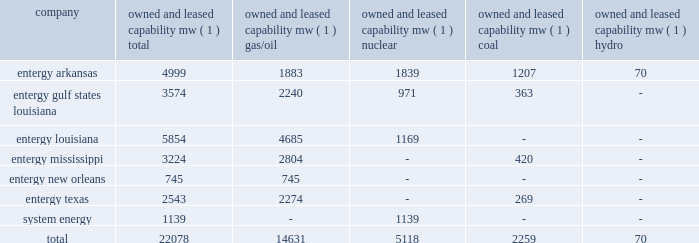Part i item 1 entergy corporation , utility operating companies , and system energy louisiana parishes in which it holds non-exclusive franchises .
Entergy louisiana's electric franchises expire during 2009-2036 .
Entergy mississippi has received from the mpsc certificates of public convenience and necessity to provide electric service to areas within 45 counties , including a number of municipalities , in western mississippi .
Under mississippi statutory law , such certificates are exclusive .
Entergy mississippi may continue to serve in such municipalities upon payment of a statutory franchise fee , regardless of whether an original municipal franchise is still in existence .
Entergy new orleans provides electric and gas service in the city of new orleans pursuant to city ordinances ( except electric service in algiers , which is provided by entergy louisiana ) .
These ordinances contain a continuing option for the city of new orleans to purchase entergy new orleans' electric and gas utility properties .
Entergy texas holds a certificate of convenience and necessity from the puct to provide electric service to areas within approximately 24 counties in eastern texas , and holds non-exclusive franchises to provide electric service in approximately 65 incorporated municipalities .
Entergy texas typically is granted 50-year franchises .
Entergy texas' electric franchises expire during 2009-2045 .
The business of system energy is limited to wholesale power sales .
It has no distribution franchises .
Property and other generation resources generating stations the total capability of the generating stations owned and leased by the utility operating companies and system energy as of december 31 , 2008 , is indicated below: .
( 1 ) "owned and leased capability" is the dependable load carrying capability as demonstrated under actual operating conditions based on the primary fuel ( assuming no curtailments ) that each station was designed to utilize .
The entergy system's load and capacity projections are reviewed periodically to assess the need and timing for additional generating capacity and interconnections .
These reviews consider existing and projected demand , the availability and price of power , the location of new load , and the economy .
Summer peak load in the entergy system service territory has averaged 21039 mw from 2002-2008 .
Due to changing use patterns , peak load growth has nearly flattened while annual energy use continues to grow .
In the 2002 time period , the entergy system's long-term capacity resources , allowing for an adequate reserve margin , were approximately 3000 mw less than the total capacity required for peak period demands .
In this time period entergy met its capacity shortages almost entirely through short-term power purchases in the wholesale spot market .
In the fall of 2002 , the entergy system began a program to add new resources to its existing generation portfolio and began a process of issuing .
What percent of the total owned and leased capability is owned by entergy louisiana? 
Computations: (5854 / 22078)
Answer: 0.26515. Part i item 1 entergy corporation , utility operating companies , and system energy louisiana parishes in which it holds non-exclusive franchises .
Entergy louisiana's electric franchises expire during 2009-2036 .
Entergy mississippi has received from the mpsc certificates of public convenience and necessity to provide electric service to areas within 45 counties , including a number of municipalities , in western mississippi .
Under mississippi statutory law , such certificates are exclusive .
Entergy mississippi may continue to serve in such municipalities upon payment of a statutory franchise fee , regardless of whether an original municipal franchise is still in existence .
Entergy new orleans provides electric and gas service in the city of new orleans pursuant to city ordinances ( except electric service in algiers , which is provided by entergy louisiana ) .
These ordinances contain a continuing option for the city of new orleans to purchase entergy new orleans' electric and gas utility properties .
Entergy texas holds a certificate of convenience and necessity from the puct to provide electric service to areas within approximately 24 counties in eastern texas , and holds non-exclusive franchises to provide electric service in approximately 65 incorporated municipalities .
Entergy texas typically is granted 50-year franchises .
Entergy texas' electric franchises expire during 2009-2045 .
The business of system energy is limited to wholesale power sales .
It has no distribution franchises .
Property and other generation resources generating stations the total capability of the generating stations owned and leased by the utility operating companies and system energy as of december 31 , 2008 , is indicated below: .
( 1 ) "owned and leased capability" is the dependable load carrying capability as demonstrated under actual operating conditions based on the primary fuel ( assuming no curtailments ) that each station was designed to utilize .
The entergy system's load and capacity projections are reviewed periodically to assess the need and timing for additional generating capacity and interconnections .
These reviews consider existing and projected demand , the availability and price of power , the location of new load , and the economy .
Summer peak load in the entergy system service territory has averaged 21039 mw from 2002-2008 .
Due to changing use patterns , peak load growth has nearly flattened while annual energy use continues to grow .
In the 2002 time period , the entergy system's long-term capacity resources , allowing for an adequate reserve margin , were approximately 3000 mw less than the total capacity required for peak period demands .
In this time period entergy met its capacity shortages almost entirely through short-term power purchases in the wholesale spot market .
In the fall of 2002 , the entergy system began a program to add new resources to its existing generation portfolio and began a process of issuing .
What portion of the total properties operated by entergy corporation are used by entergy arkansas? 
Computations: (4999 / 22078)
Answer: 0.22642. 